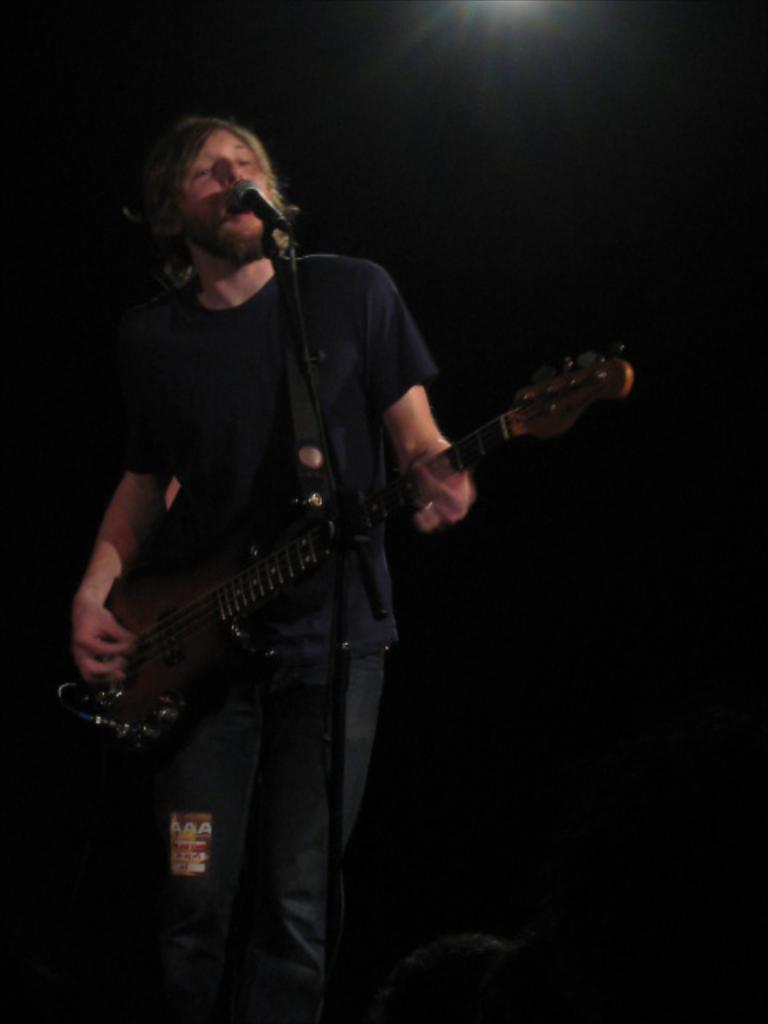What is the main subject of the image? There is a person in the image. What is the person doing in the image? The person is standing in the image. What object is the person holding in the image? The person is holding a guitar in his hand. What type of earth can be seen in the image? There is no earth visible in the image; it features a person standing and holding a guitar. What action is the person taking to cause the guitar to play music in the image? The image does not show the person playing the guitar, so it cannot be determined if they are taking any action to cause the guitar to play music. 